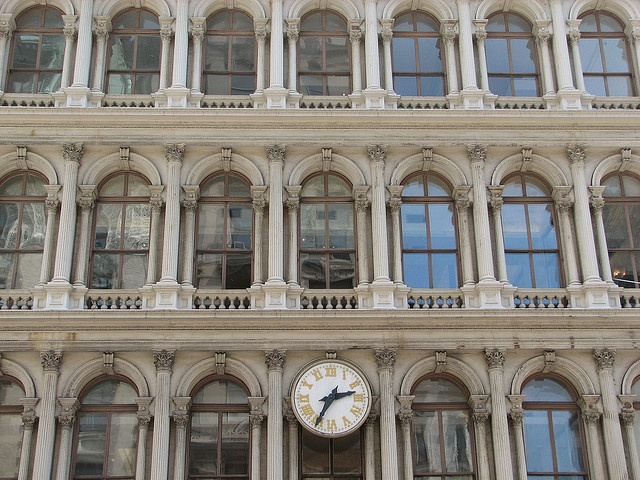Describe the objects in this image and their specific colors. I can see a clock in darkgray, lightgray, tan, and gray tones in this image. 